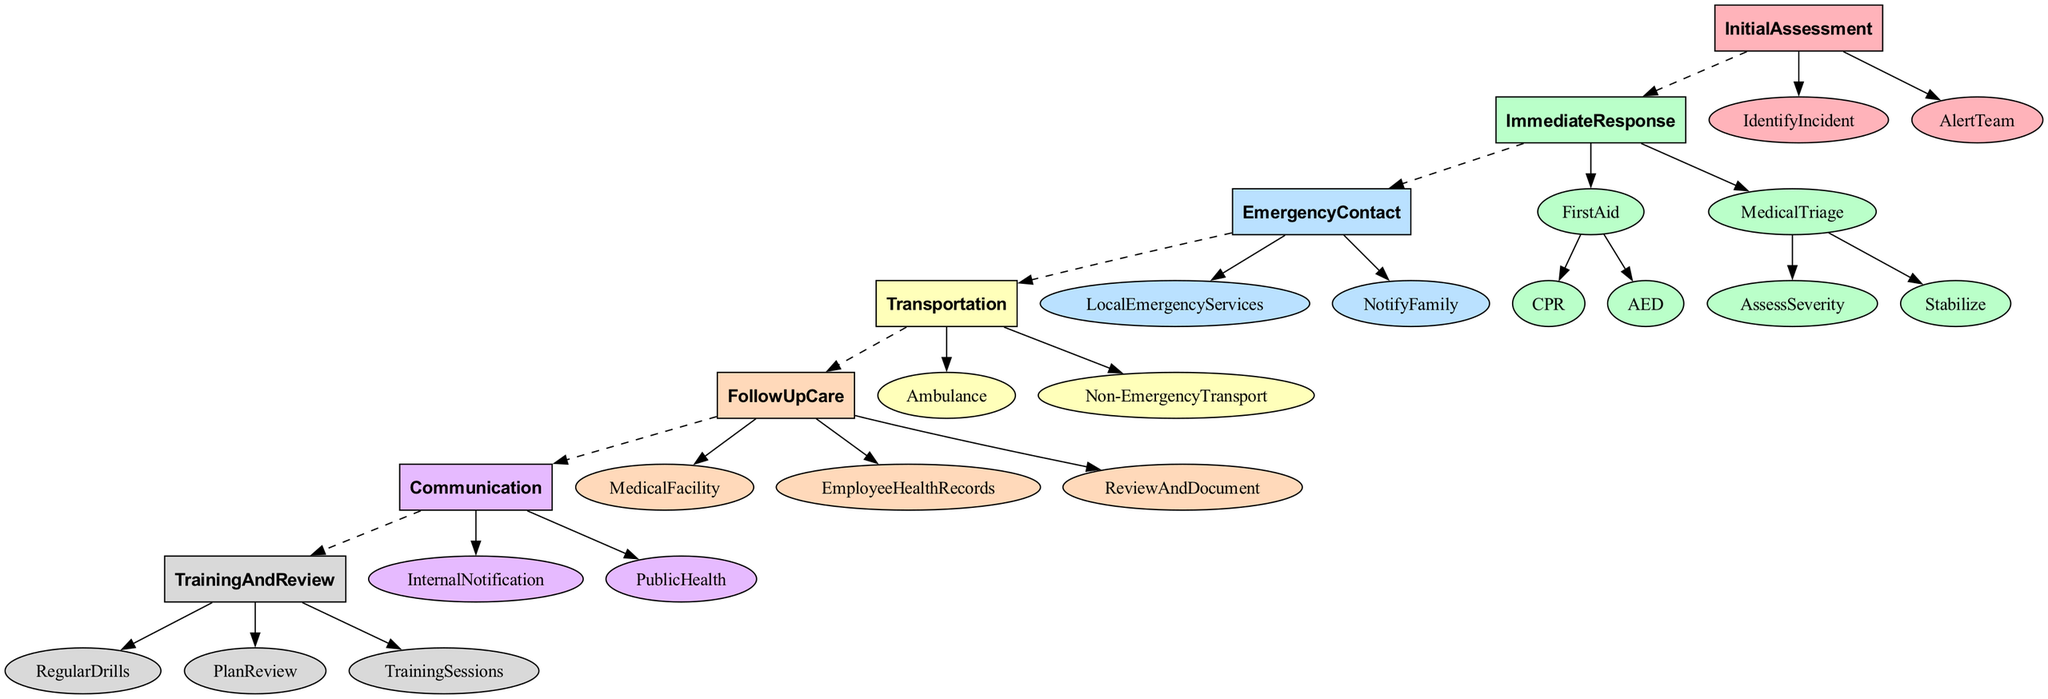What is the first step in the Workplace Emergency Response Plan? The first step is "Initial Assessment", where signs of health incidents are recognized and the emergency response team is alerted.
Answer: Initial Assessment How many main sections are there in the Workplace Emergency Response Plan? The plan consists of six main sections: Initial Assessment, Immediate Response, Emergency Contact, Transportation, Follow Up Care, and Communication.
Answer: Six Which section follows "Immediate Response"? The "Emergency Contact" section follows "Immediate Response", indicating the next phase after responding to the health incident.
Answer: Emergency Contact What is the action under "First Aid" that involves using equipment? The action is to "Use Automated External Defibrillator (AED)", which is an important step in administering first aid for certain emergencies.
Answer: Use Automated External Defibrillator (AED) What should be done immediately after assessing severity during "Medical Triage"? The next action is "Stabilize", which involves applying necessary stabilization techniques based on the assessment.
Answer: Stabilize Which action is included in the "Transportation" section? The action "Coordinate ambulance transportation if needed" is included in this section to ensure prompt medical assistance.
Answer: Coordinate ambulance transportation if needed In which section is employee training included? Employee training is included in the "Training and Review" section, which focuses on conducting drills and providing training sessions.
Answer: Training and Review How does the "Communication" section ensure timely notification? The section emphasizes "Inform all employees of the incident in a timely manner", ensuring that all staff are aware of emergencies quickly.
Answer: Inform all employees of the incident in a timely manner What is the frequency of the "Plan Review" in the "Training and Review" section? The plan review is conducted "annually", which implies that the emergency response plan is evaluated and updated once a year.
Answer: Annually 